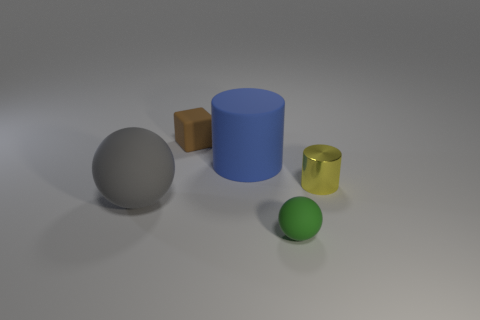Add 2 metallic objects. How many objects exist? 7 Subtract all cubes. How many objects are left? 4 Add 1 yellow cylinders. How many yellow cylinders are left? 2 Add 3 tiny green matte balls. How many tiny green matte balls exist? 4 Subtract 0 red cubes. How many objects are left? 5 Subtract all tiny cylinders. Subtract all small yellow cylinders. How many objects are left? 3 